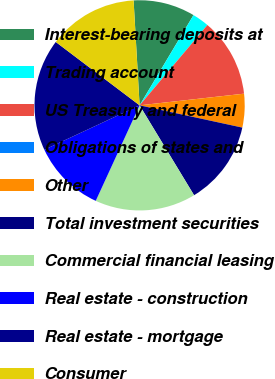<chart> <loc_0><loc_0><loc_500><loc_500><pie_chart><fcel>Interest-bearing deposits at<fcel>Trading account<fcel>US Treasury and federal<fcel>Obligations of states and<fcel>Other<fcel>Total investment securities<fcel>Commercial financial leasing<fcel>Real estate - construction<fcel>Real estate - mortgage<fcel>Consumer<nl><fcel>9.48%<fcel>2.59%<fcel>12.07%<fcel>0.0%<fcel>5.17%<fcel>12.93%<fcel>15.52%<fcel>11.21%<fcel>17.24%<fcel>13.79%<nl></chart> 